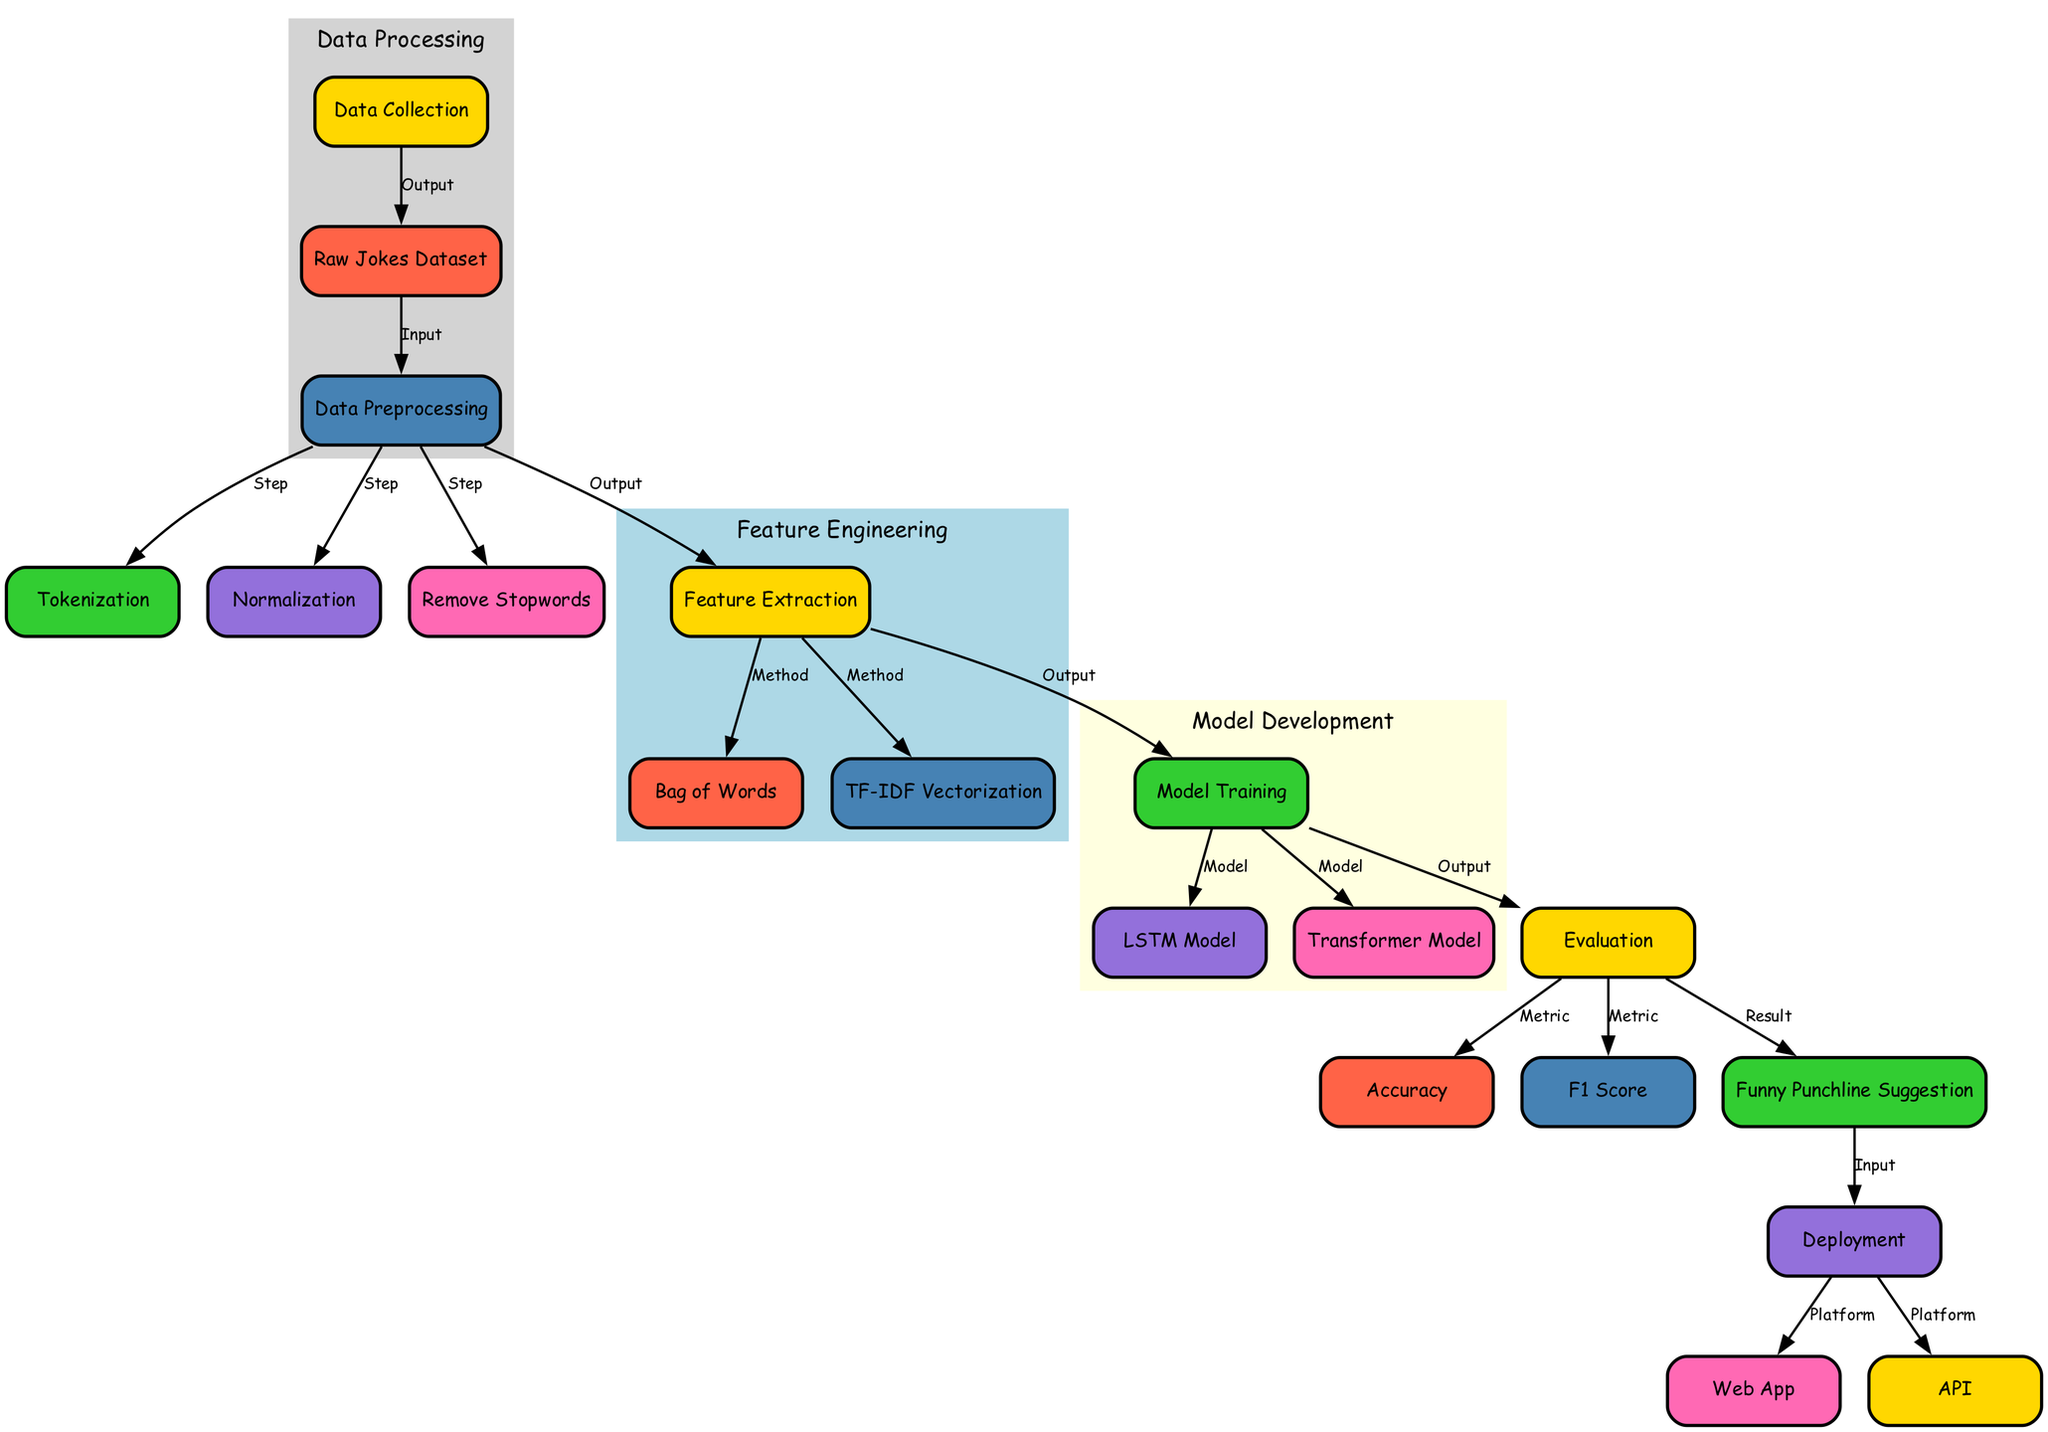What is the initial step in the diagram? The diagram begins with the node labeled "Data Collection," which represents the primary action to gather data for the following processes.
Answer: Data Collection How many models are involved in the model training phase? In the "Model Training" phase, there are two specific models mentioned: the LSTM model and the Transformer model, indicating that both are utilized in training.
Answer: Two Which evaluation metrics are used in the diagram? The evaluation phase includes two metrics specifically named: "Accuracy" and "F1 Score," which are both essential for assessing model performance.
Answer: Accuracy, F1 Score What is the output of the evaluation stage? The "Evaluation" stage leads to three outputs, with "Funny Punchline Suggestion" being one of them, indicating the ultimate goal of the model evaluation.
Answer: Funny Punchline Suggestion How does the feature extraction phase interact with data preprocessing? The "Feature Extraction" node is an output from the "Data Preprocessing" phase, indicating that it's dependent on the preprocessing steps such as tokenization, normalization, and stopword removal.
Answer: Feature Extraction Which two platforms are used for deployment in the diagram? The deployment phase leads to two platforms, specifically a "Web App" and an "API," which indicates where the final output suggestions can be accessed.
Answer: Web App, API What is the purpose of normalization in the data preprocessing phase? Normalization within the data preprocessing phase ensures that the data is standardized, which is crucial for leveling the input features before they are further processed.
Answer: Standardization From data collection to punchline suggestion, how many steps are there? Counting the steps from "Data Collection" through to "Funny Punchline Suggestion" yields six key phases: data collection, preprocessing, feature extraction, model training, evaluation, and suggestion.
Answer: Six How are the feature extraction methods categorized? The methods of feature extraction, namely "Bag of Words" and "TF-IDF Vectorization," are listed as outputs from the feature extraction node, indicating different approaches used to convert text data into numerical format.
Answer: Bag of Words, TF-IDF Vectorization 